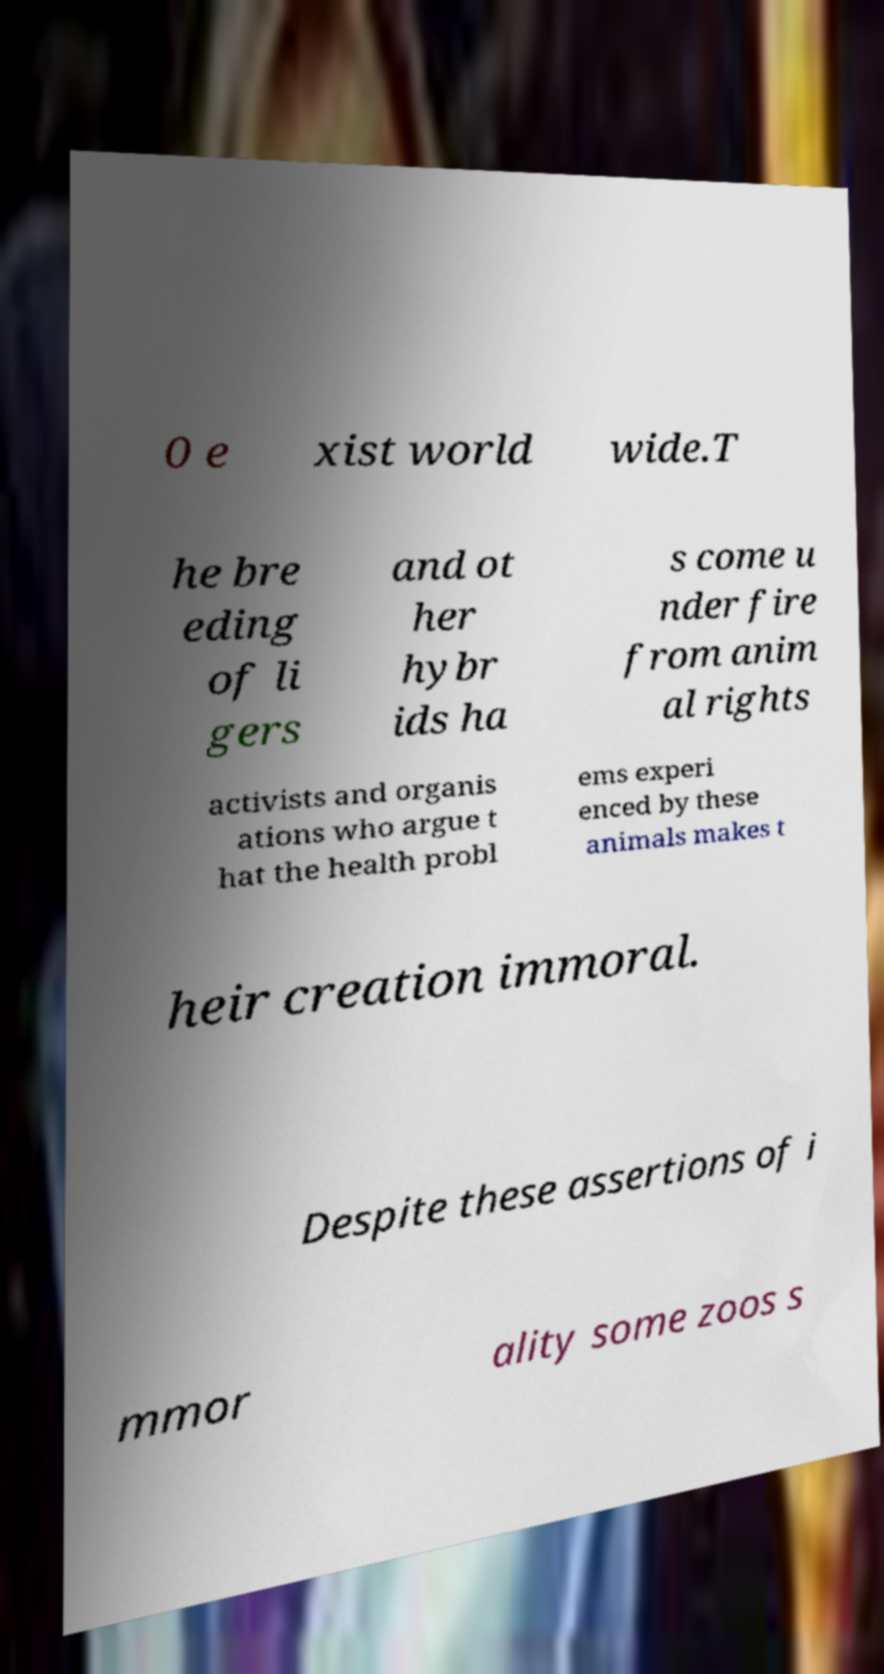Can you read and provide the text displayed in the image?This photo seems to have some interesting text. Can you extract and type it out for me? 0 e xist world wide.T he bre eding of li gers and ot her hybr ids ha s come u nder fire from anim al rights activists and organis ations who argue t hat the health probl ems experi enced by these animals makes t heir creation immoral. Despite these assertions of i mmor ality some zoos s 